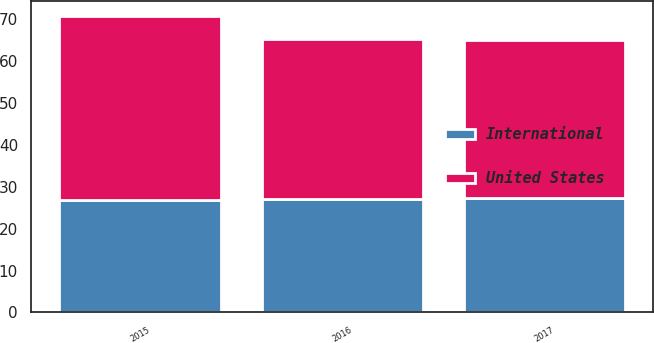Convert chart. <chart><loc_0><loc_0><loc_500><loc_500><stacked_bar_chart><ecel><fcel>2017<fcel>2016<fcel>2015<nl><fcel>International<fcel>27.3<fcel>27<fcel>26.8<nl><fcel>United States<fcel>37.8<fcel>38.3<fcel>43.9<nl></chart> 